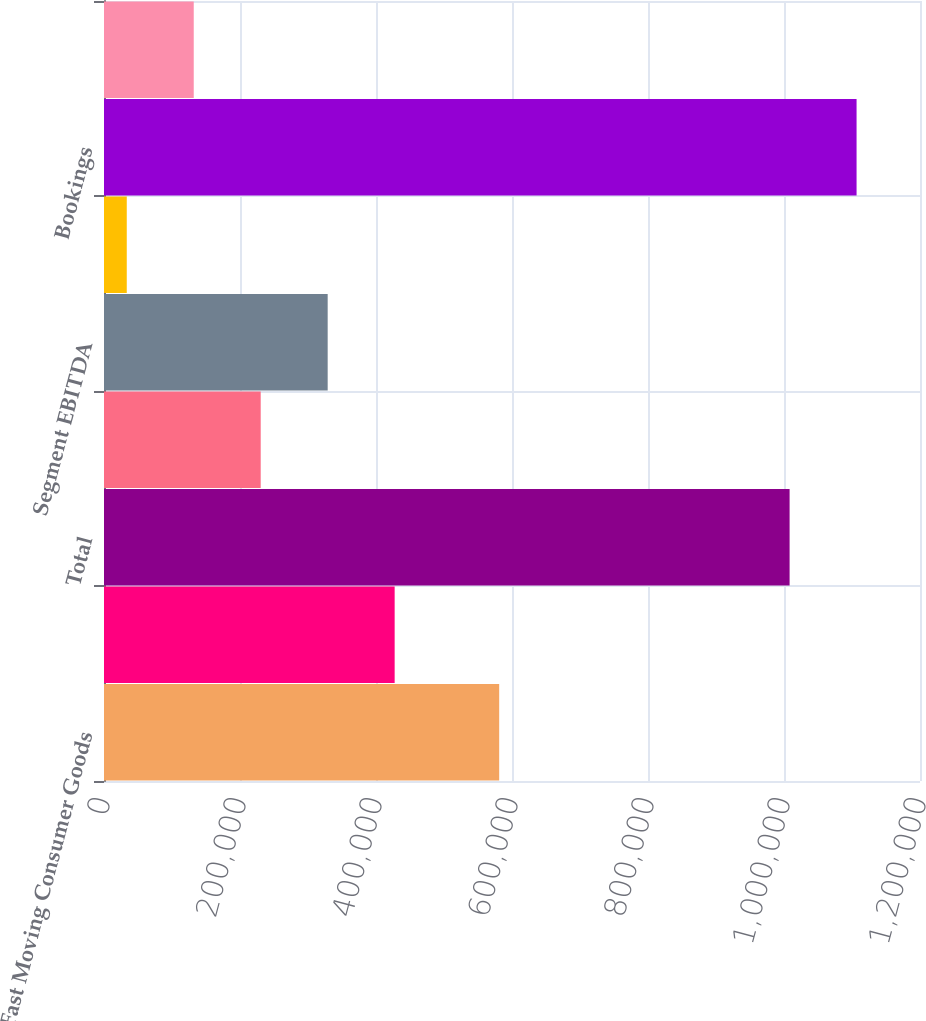Convert chart to OTSL. <chart><loc_0><loc_0><loc_500><loc_500><bar_chart><fcel>Fast Moving Consumer Goods<fcel>Industrial<fcel>Total<fcel>Segment earnings<fcel>Segment EBITDA<fcel>Depreciation and amortization<fcel>Bookings<fcel>Backlog<nl><fcel>581158<fcel>427431<fcel>1.00824e+06<fcel>230457<fcel>328944<fcel>33482<fcel>1.10672e+06<fcel>131969<nl></chart> 